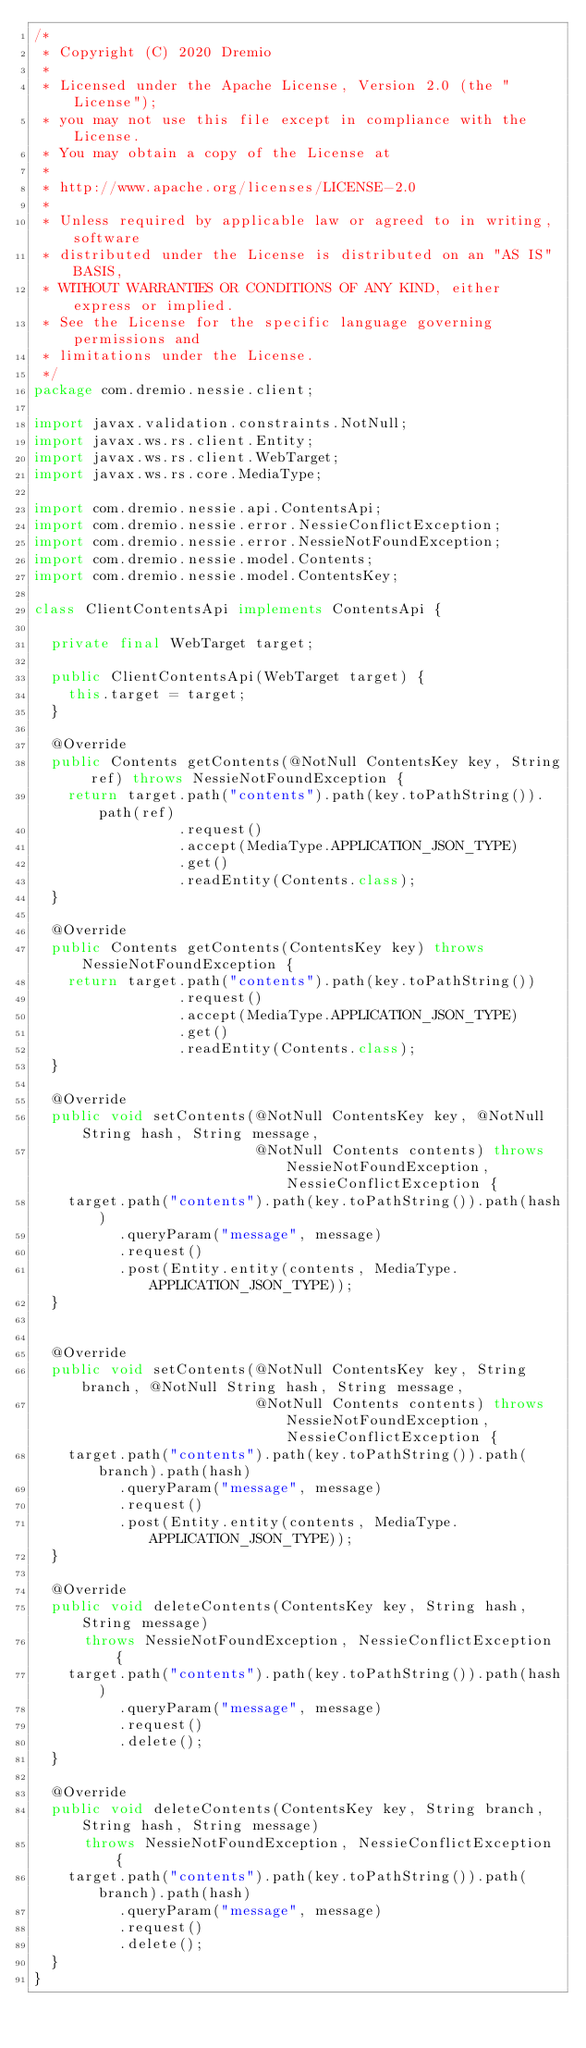Convert code to text. <code><loc_0><loc_0><loc_500><loc_500><_Java_>/*
 * Copyright (C) 2020 Dremio
 *
 * Licensed under the Apache License, Version 2.0 (the "License");
 * you may not use this file except in compliance with the License.
 * You may obtain a copy of the License at
 *
 * http://www.apache.org/licenses/LICENSE-2.0
 *
 * Unless required by applicable law or agreed to in writing, software
 * distributed under the License is distributed on an "AS IS" BASIS,
 * WITHOUT WARRANTIES OR CONDITIONS OF ANY KIND, either express or implied.
 * See the License for the specific language governing permissions and
 * limitations under the License.
 */
package com.dremio.nessie.client;

import javax.validation.constraints.NotNull;
import javax.ws.rs.client.Entity;
import javax.ws.rs.client.WebTarget;
import javax.ws.rs.core.MediaType;

import com.dremio.nessie.api.ContentsApi;
import com.dremio.nessie.error.NessieConflictException;
import com.dremio.nessie.error.NessieNotFoundException;
import com.dremio.nessie.model.Contents;
import com.dremio.nessie.model.ContentsKey;

class ClientContentsApi implements ContentsApi {

  private final WebTarget target;

  public ClientContentsApi(WebTarget target) {
    this.target = target;
  }

  @Override
  public Contents getContents(@NotNull ContentsKey key, String ref) throws NessieNotFoundException {
    return target.path("contents").path(key.toPathString()).path(ref)
                 .request()
                 .accept(MediaType.APPLICATION_JSON_TYPE)
                 .get()
                 .readEntity(Contents.class);
  }

  @Override
  public Contents getContents(ContentsKey key) throws NessieNotFoundException {
    return target.path("contents").path(key.toPathString())
                 .request()
                 .accept(MediaType.APPLICATION_JSON_TYPE)
                 .get()
                 .readEntity(Contents.class);
  }

  @Override
  public void setContents(@NotNull ContentsKey key, @NotNull String hash, String message,
                          @NotNull Contents contents) throws NessieNotFoundException, NessieConflictException {
    target.path("contents").path(key.toPathString()).path(hash)
          .queryParam("message", message)
          .request()
          .post(Entity.entity(contents, MediaType.APPLICATION_JSON_TYPE));
  }


  @Override
  public void setContents(@NotNull ContentsKey key, String branch, @NotNull String hash, String message,
                          @NotNull Contents contents) throws NessieNotFoundException, NessieConflictException {
    target.path("contents").path(key.toPathString()).path(branch).path(hash)
          .queryParam("message", message)
          .request()
          .post(Entity.entity(contents, MediaType.APPLICATION_JSON_TYPE));
  }

  @Override
  public void deleteContents(ContentsKey key, String hash, String message)
      throws NessieNotFoundException, NessieConflictException {
    target.path("contents").path(key.toPathString()).path(hash)
          .queryParam("message", message)
          .request()
          .delete();
  }

  @Override
  public void deleteContents(ContentsKey key, String branch, String hash, String message)
      throws NessieNotFoundException, NessieConflictException {
    target.path("contents").path(key.toPathString()).path(branch).path(hash)
          .queryParam("message", message)
          .request()
          .delete();
  }
}
</code> 